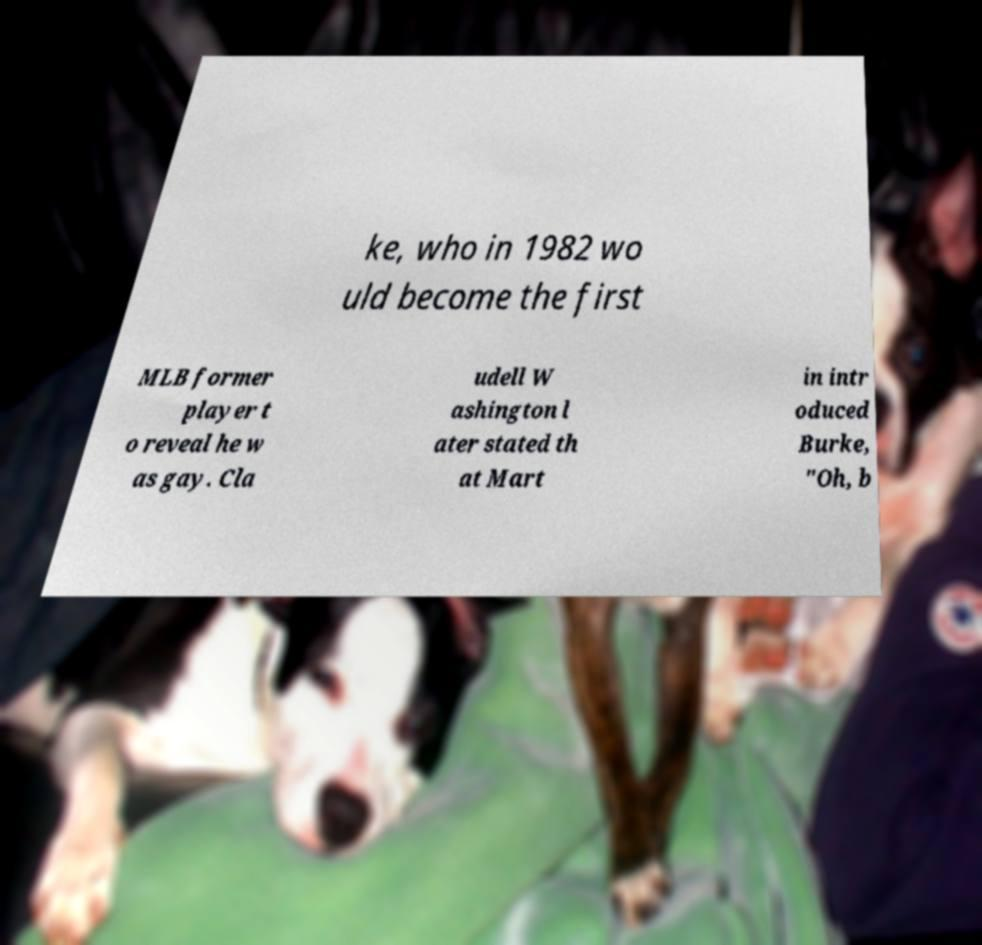Can you accurately transcribe the text from the provided image for me? ke, who in 1982 wo uld become the first MLB former player t o reveal he w as gay. Cla udell W ashington l ater stated th at Mart in intr oduced Burke, "Oh, b 